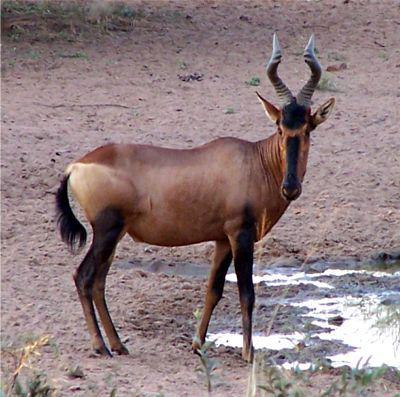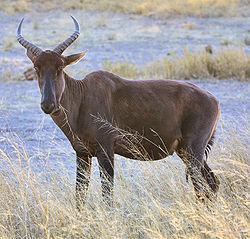The first image is the image on the left, the second image is the image on the right. Examine the images to the left and right. Is the description "The right hand image contains an animal facing left." accurate? Answer yes or no. Yes. 